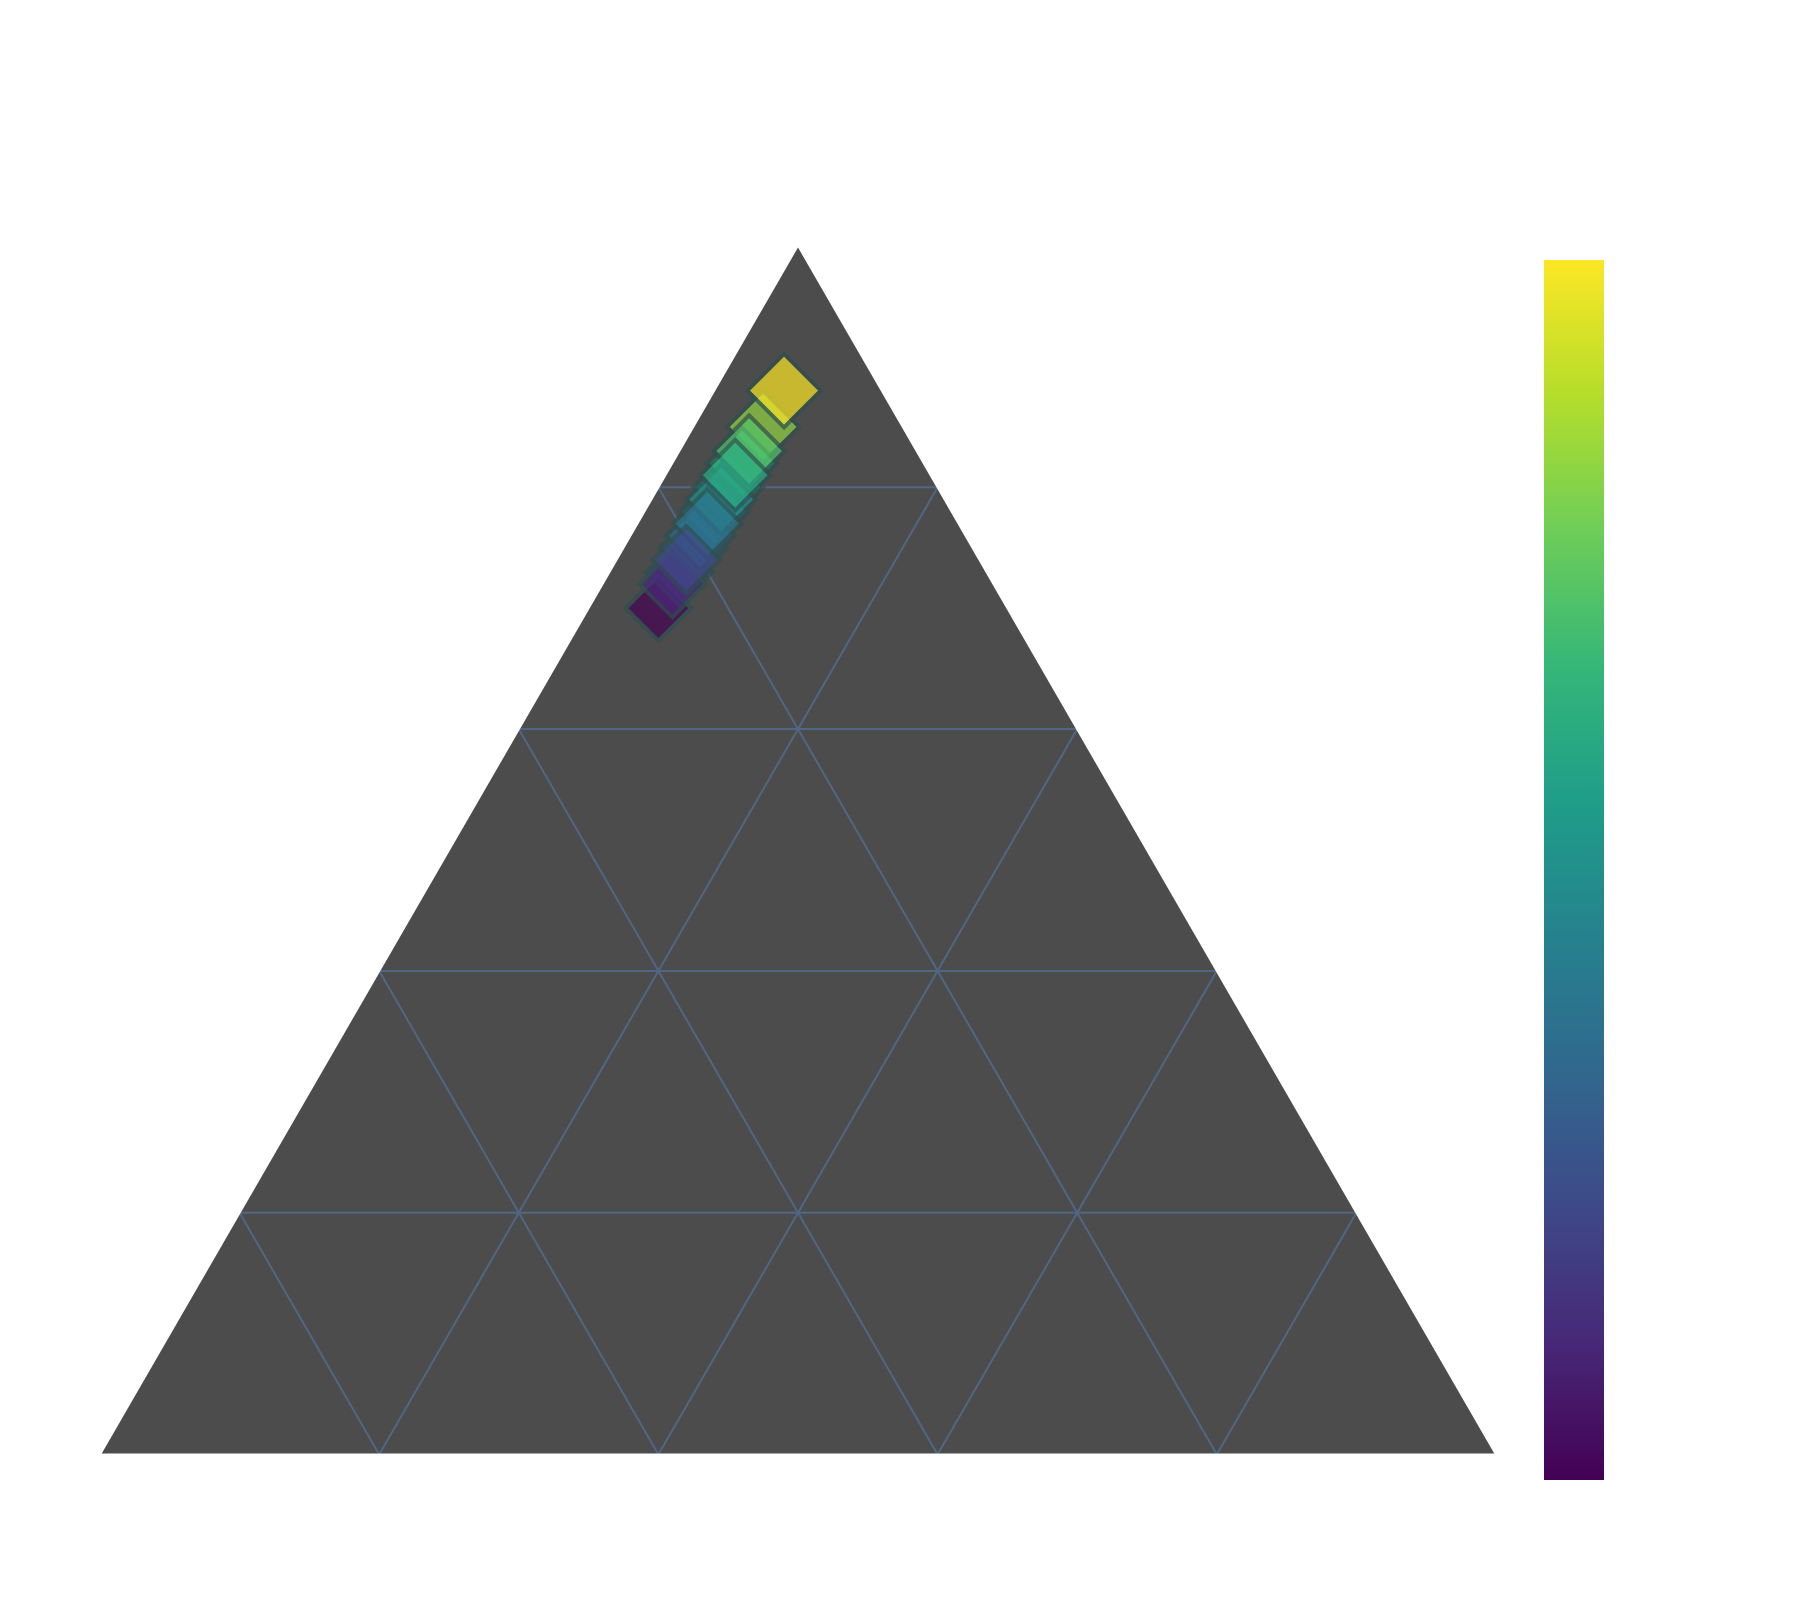What's the title of the figure? The figure's title is usually displayed prominently at the top.
Answer: Cheniere Energy Revenue Composition How many different data points are plotted in the figure? Each point on the ternary plot represents a different data entry. Count the distinct markers.
Answer: 15 What color scale is used for the data points in the figure? The color scale is typically displayed as a color bar in the plot, often labeled.
Answer: Viridis Which axis represents the percentage of LNG Exports? In a ternary plot, the axes are typically labeled. Identify the one labeled as LNG Exports.
Answer: The left axis What is the minimum value of Domestic Gas Sales? Look at the ternary plot and identify the lowest value on the Domestic Gas Sales axis.
Answer: 7% What is the average percentage of Other Services across all data points? Since Other Services seem constant, find the value present across all points. Add the percentages and divide by the total number of data points. (5 * 15) / 15 = 5.
Answer: 5% What is the highest value for LNG Exports observed in the figure? Among the plotted points, identify the one with the highest value on the LNG Exports axis.
Answer: 88% Is there a point where Domestic Gas Sales and Other Services are equal? Check if any data point has equal percentages on the Domestic Gas Sales and Other Services axes.
Answer: No How do LNG Exports compare between the data points with the highest and lowest Domestic Gas Sales? Identify the points with the highest (7%) and lowest (25%) Domestic Gas Sales and compare their LNG Exports. 88% (highest Domestic Gas Sales) vs 70% (lowest).
Answer: 88% vs 70% What is the overall trend between LNG Exports and Domestic Gas Sales in the figure? Look at the distribution of data points regarding LNG Exports and Domestic Gas Sales. Inverse relationships typically lead to a downward trend.
Answer: Inverse trend (as LNG Exports increase, Domestic Gas Sales decrease) Do we have any point that lies exactly in the middle of the ternary plot? The central point would have approximately equal percentages for LNG Exports, Domestic Gas Sales, and Other Services.
Answer: No 